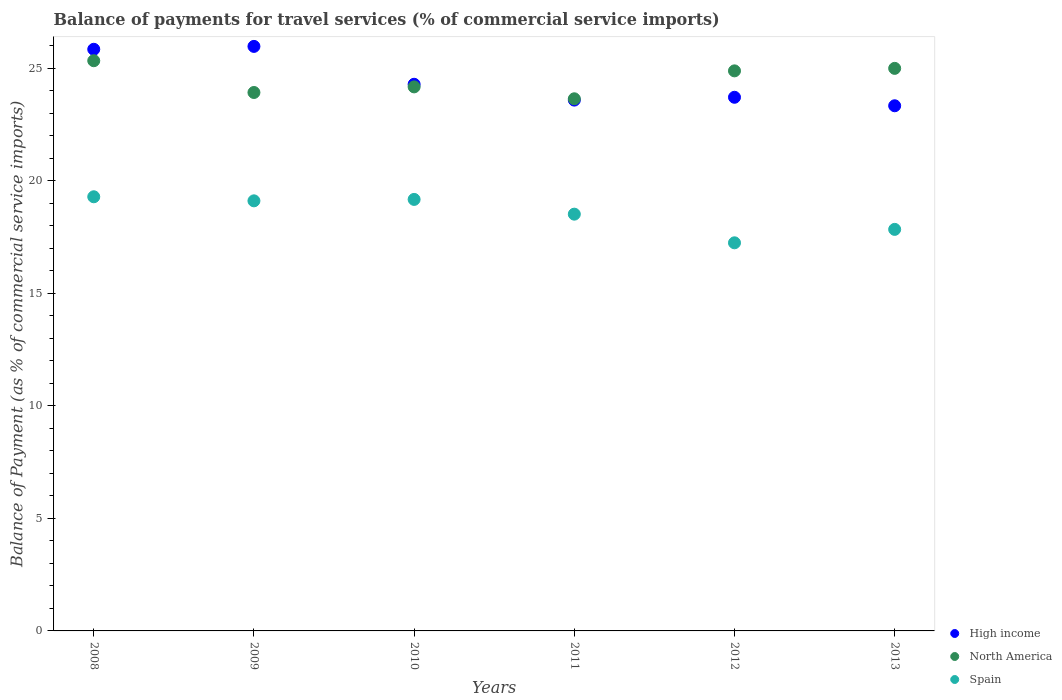How many different coloured dotlines are there?
Your answer should be very brief. 3. What is the balance of payments for travel services in Spain in 2013?
Your answer should be very brief. 17.84. Across all years, what is the maximum balance of payments for travel services in North America?
Keep it short and to the point. 25.33. Across all years, what is the minimum balance of payments for travel services in Spain?
Give a very brief answer. 17.24. In which year was the balance of payments for travel services in North America minimum?
Keep it short and to the point. 2011. What is the total balance of payments for travel services in North America in the graph?
Ensure brevity in your answer.  146.91. What is the difference between the balance of payments for travel services in North America in 2009 and that in 2013?
Provide a succinct answer. -1.07. What is the difference between the balance of payments for travel services in Spain in 2011 and the balance of payments for travel services in North America in 2012?
Your answer should be compact. -6.36. What is the average balance of payments for travel services in High income per year?
Offer a terse response. 24.45. In the year 2008, what is the difference between the balance of payments for travel services in High income and balance of payments for travel services in North America?
Give a very brief answer. 0.51. What is the ratio of the balance of payments for travel services in Spain in 2009 to that in 2011?
Give a very brief answer. 1.03. Is the balance of payments for travel services in High income in 2012 less than that in 2013?
Offer a very short reply. No. Is the difference between the balance of payments for travel services in High income in 2010 and 2011 greater than the difference between the balance of payments for travel services in North America in 2010 and 2011?
Provide a succinct answer. Yes. What is the difference between the highest and the second highest balance of payments for travel services in High income?
Make the answer very short. 0.13. What is the difference between the highest and the lowest balance of payments for travel services in North America?
Provide a succinct answer. 1.69. In how many years, is the balance of payments for travel services in North America greater than the average balance of payments for travel services in North America taken over all years?
Provide a short and direct response. 3. Is the sum of the balance of payments for travel services in High income in 2008 and 2009 greater than the maximum balance of payments for travel services in Spain across all years?
Your answer should be very brief. Yes. Is it the case that in every year, the sum of the balance of payments for travel services in North America and balance of payments for travel services in Spain  is greater than the balance of payments for travel services in High income?
Give a very brief answer. Yes. Does the balance of payments for travel services in High income monotonically increase over the years?
Offer a terse response. No. Is the balance of payments for travel services in North America strictly greater than the balance of payments for travel services in Spain over the years?
Provide a short and direct response. Yes. What is the difference between two consecutive major ticks on the Y-axis?
Your answer should be compact. 5. Are the values on the major ticks of Y-axis written in scientific E-notation?
Ensure brevity in your answer.  No. Does the graph contain any zero values?
Provide a short and direct response. No. What is the title of the graph?
Provide a succinct answer. Balance of payments for travel services (% of commercial service imports). What is the label or title of the Y-axis?
Your answer should be compact. Balance of Payment (as % of commercial service imports). What is the Balance of Payment (as % of commercial service imports) of High income in 2008?
Your response must be concise. 25.84. What is the Balance of Payment (as % of commercial service imports) of North America in 2008?
Your answer should be compact. 25.33. What is the Balance of Payment (as % of commercial service imports) in Spain in 2008?
Offer a terse response. 19.28. What is the Balance of Payment (as % of commercial service imports) of High income in 2009?
Give a very brief answer. 25.96. What is the Balance of Payment (as % of commercial service imports) of North America in 2009?
Your response must be concise. 23.92. What is the Balance of Payment (as % of commercial service imports) of Spain in 2009?
Provide a short and direct response. 19.1. What is the Balance of Payment (as % of commercial service imports) in High income in 2010?
Your response must be concise. 24.28. What is the Balance of Payment (as % of commercial service imports) of North America in 2010?
Offer a terse response. 24.17. What is the Balance of Payment (as % of commercial service imports) of Spain in 2010?
Provide a succinct answer. 19.17. What is the Balance of Payment (as % of commercial service imports) in High income in 2011?
Ensure brevity in your answer.  23.58. What is the Balance of Payment (as % of commercial service imports) of North America in 2011?
Provide a short and direct response. 23.64. What is the Balance of Payment (as % of commercial service imports) in Spain in 2011?
Make the answer very short. 18.51. What is the Balance of Payment (as % of commercial service imports) of High income in 2012?
Offer a very short reply. 23.7. What is the Balance of Payment (as % of commercial service imports) of North America in 2012?
Provide a short and direct response. 24.88. What is the Balance of Payment (as % of commercial service imports) in Spain in 2012?
Your answer should be compact. 17.24. What is the Balance of Payment (as % of commercial service imports) of High income in 2013?
Your answer should be compact. 23.33. What is the Balance of Payment (as % of commercial service imports) of North America in 2013?
Keep it short and to the point. 24.99. What is the Balance of Payment (as % of commercial service imports) of Spain in 2013?
Give a very brief answer. 17.84. Across all years, what is the maximum Balance of Payment (as % of commercial service imports) of High income?
Keep it short and to the point. 25.96. Across all years, what is the maximum Balance of Payment (as % of commercial service imports) in North America?
Your answer should be very brief. 25.33. Across all years, what is the maximum Balance of Payment (as % of commercial service imports) of Spain?
Offer a terse response. 19.28. Across all years, what is the minimum Balance of Payment (as % of commercial service imports) in High income?
Your answer should be very brief. 23.33. Across all years, what is the minimum Balance of Payment (as % of commercial service imports) in North America?
Your response must be concise. 23.64. Across all years, what is the minimum Balance of Payment (as % of commercial service imports) of Spain?
Your answer should be very brief. 17.24. What is the total Balance of Payment (as % of commercial service imports) in High income in the graph?
Offer a terse response. 146.69. What is the total Balance of Payment (as % of commercial service imports) of North America in the graph?
Provide a succinct answer. 146.91. What is the total Balance of Payment (as % of commercial service imports) in Spain in the graph?
Ensure brevity in your answer.  111.14. What is the difference between the Balance of Payment (as % of commercial service imports) of High income in 2008 and that in 2009?
Offer a terse response. -0.13. What is the difference between the Balance of Payment (as % of commercial service imports) in North America in 2008 and that in 2009?
Ensure brevity in your answer.  1.41. What is the difference between the Balance of Payment (as % of commercial service imports) of Spain in 2008 and that in 2009?
Offer a very short reply. 0.18. What is the difference between the Balance of Payment (as % of commercial service imports) in High income in 2008 and that in 2010?
Make the answer very short. 1.55. What is the difference between the Balance of Payment (as % of commercial service imports) of North America in 2008 and that in 2010?
Keep it short and to the point. 1.16. What is the difference between the Balance of Payment (as % of commercial service imports) of Spain in 2008 and that in 2010?
Your response must be concise. 0.12. What is the difference between the Balance of Payment (as % of commercial service imports) of High income in 2008 and that in 2011?
Make the answer very short. 2.26. What is the difference between the Balance of Payment (as % of commercial service imports) of North America in 2008 and that in 2011?
Offer a very short reply. 1.69. What is the difference between the Balance of Payment (as % of commercial service imports) in Spain in 2008 and that in 2011?
Provide a succinct answer. 0.77. What is the difference between the Balance of Payment (as % of commercial service imports) in High income in 2008 and that in 2012?
Offer a terse response. 2.13. What is the difference between the Balance of Payment (as % of commercial service imports) of North America in 2008 and that in 2012?
Provide a succinct answer. 0.45. What is the difference between the Balance of Payment (as % of commercial service imports) in Spain in 2008 and that in 2012?
Offer a terse response. 2.05. What is the difference between the Balance of Payment (as % of commercial service imports) of High income in 2008 and that in 2013?
Offer a terse response. 2.51. What is the difference between the Balance of Payment (as % of commercial service imports) in North America in 2008 and that in 2013?
Your answer should be very brief. 0.34. What is the difference between the Balance of Payment (as % of commercial service imports) in Spain in 2008 and that in 2013?
Make the answer very short. 1.45. What is the difference between the Balance of Payment (as % of commercial service imports) in High income in 2009 and that in 2010?
Give a very brief answer. 1.68. What is the difference between the Balance of Payment (as % of commercial service imports) in North America in 2009 and that in 2010?
Offer a terse response. -0.25. What is the difference between the Balance of Payment (as % of commercial service imports) in Spain in 2009 and that in 2010?
Ensure brevity in your answer.  -0.06. What is the difference between the Balance of Payment (as % of commercial service imports) in High income in 2009 and that in 2011?
Provide a succinct answer. 2.39. What is the difference between the Balance of Payment (as % of commercial service imports) of North America in 2009 and that in 2011?
Your answer should be compact. 0.28. What is the difference between the Balance of Payment (as % of commercial service imports) in Spain in 2009 and that in 2011?
Keep it short and to the point. 0.59. What is the difference between the Balance of Payment (as % of commercial service imports) of High income in 2009 and that in 2012?
Your response must be concise. 2.26. What is the difference between the Balance of Payment (as % of commercial service imports) in North America in 2009 and that in 2012?
Your response must be concise. -0.96. What is the difference between the Balance of Payment (as % of commercial service imports) in Spain in 2009 and that in 2012?
Make the answer very short. 1.86. What is the difference between the Balance of Payment (as % of commercial service imports) of High income in 2009 and that in 2013?
Your answer should be compact. 2.64. What is the difference between the Balance of Payment (as % of commercial service imports) in North America in 2009 and that in 2013?
Keep it short and to the point. -1.07. What is the difference between the Balance of Payment (as % of commercial service imports) in Spain in 2009 and that in 2013?
Make the answer very short. 1.27. What is the difference between the Balance of Payment (as % of commercial service imports) in High income in 2010 and that in 2011?
Offer a terse response. 0.7. What is the difference between the Balance of Payment (as % of commercial service imports) of North America in 2010 and that in 2011?
Offer a terse response. 0.53. What is the difference between the Balance of Payment (as % of commercial service imports) of Spain in 2010 and that in 2011?
Offer a terse response. 0.65. What is the difference between the Balance of Payment (as % of commercial service imports) of High income in 2010 and that in 2012?
Offer a terse response. 0.58. What is the difference between the Balance of Payment (as % of commercial service imports) in North America in 2010 and that in 2012?
Provide a succinct answer. -0.71. What is the difference between the Balance of Payment (as % of commercial service imports) in Spain in 2010 and that in 2012?
Your answer should be compact. 1.93. What is the difference between the Balance of Payment (as % of commercial service imports) in High income in 2010 and that in 2013?
Ensure brevity in your answer.  0.95. What is the difference between the Balance of Payment (as % of commercial service imports) of North America in 2010 and that in 2013?
Give a very brief answer. -0.82. What is the difference between the Balance of Payment (as % of commercial service imports) of Spain in 2010 and that in 2013?
Offer a very short reply. 1.33. What is the difference between the Balance of Payment (as % of commercial service imports) in High income in 2011 and that in 2012?
Your answer should be compact. -0.13. What is the difference between the Balance of Payment (as % of commercial service imports) in North America in 2011 and that in 2012?
Ensure brevity in your answer.  -1.24. What is the difference between the Balance of Payment (as % of commercial service imports) of Spain in 2011 and that in 2012?
Ensure brevity in your answer.  1.27. What is the difference between the Balance of Payment (as % of commercial service imports) of High income in 2011 and that in 2013?
Provide a short and direct response. 0.25. What is the difference between the Balance of Payment (as % of commercial service imports) in North America in 2011 and that in 2013?
Your answer should be compact. -1.35. What is the difference between the Balance of Payment (as % of commercial service imports) of Spain in 2011 and that in 2013?
Provide a succinct answer. 0.68. What is the difference between the Balance of Payment (as % of commercial service imports) in High income in 2012 and that in 2013?
Give a very brief answer. 0.38. What is the difference between the Balance of Payment (as % of commercial service imports) in North America in 2012 and that in 2013?
Provide a succinct answer. -0.11. What is the difference between the Balance of Payment (as % of commercial service imports) in Spain in 2012 and that in 2013?
Offer a very short reply. -0.6. What is the difference between the Balance of Payment (as % of commercial service imports) in High income in 2008 and the Balance of Payment (as % of commercial service imports) in North America in 2009?
Make the answer very short. 1.92. What is the difference between the Balance of Payment (as % of commercial service imports) of High income in 2008 and the Balance of Payment (as % of commercial service imports) of Spain in 2009?
Ensure brevity in your answer.  6.73. What is the difference between the Balance of Payment (as % of commercial service imports) of North America in 2008 and the Balance of Payment (as % of commercial service imports) of Spain in 2009?
Provide a short and direct response. 6.22. What is the difference between the Balance of Payment (as % of commercial service imports) in High income in 2008 and the Balance of Payment (as % of commercial service imports) in North America in 2010?
Your answer should be very brief. 1.67. What is the difference between the Balance of Payment (as % of commercial service imports) of High income in 2008 and the Balance of Payment (as % of commercial service imports) of Spain in 2010?
Your answer should be compact. 6.67. What is the difference between the Balance of Payment (as % of commercial service imports) in North America in 2008 and the Balance of Payment (as % of commercial service imports) in Spain in 2010?
Ensure brevity in your answer.  6.16. What is the difference between the Balance of Payment (as % of commercial service imports) in High income in 2008 and the Balance of Payment (as % of commercial service imports) in North America in 2011?
Provide a succinct answer. 2.2. What is the difference between the Balance of Payment (as % of commercial service imports) of High income in 2008 and the Balance of Payment (as % of commercial service imports) of Spain in 2011?
Give a very brief answer. 7.32. What is the difference between the Balance of Payment (as % of commercial service imports) of North America in 2008 and the Balance of Payment (as % of commercial service imports) of Spain in 2011?
Offer a very short reply. 6.82. What is the difference between the Balance of Payment (as % of commercial service imports) of High income in 2008 and the Balance of Payment (as % of commercial service imports) of North America in 2012?
Provide a short and direct response. 0.96. What is the difference between the Balance of Payment (as % of commercial service imports) in High income in 2008 and the Balance of Payment (as % of commercial service imports) in Spain in 2012?
Make the answer very short. 8.6. What is the difference between the Balance of Payment (as % of commercial service imports) in North America in 2008 and the Balance of Payment (as % of commercial service imports) in Spain in 2012?
Provide a succinct answer. 8.09. What is the difference between the Balance of Payment (as % of commercial service imports) in High income in 2008 and the Balance of Payment (as % of commercial service imports) in North America in 2013?
Offer a terse response. 0.85. What is the difference between the Balance of Payment (as % of commercial service imports) in High income in 2008 and the Balance of Payment (as % of commercial service imports) in Spain in 2013?
Offer a very short reply. 8. What is the difference between the Balance of Payment (as % of commercial service imports) of North America in 2008 and the Balance of Payment (as % of commercial service imports) of Spain in 2013?
Provide a succinct answer. 7.49. What is the difference between the Balance of Payment (as % of commercial service imports) of High income in 2009 and the Balance of Payment (as % of commercial service imports) of North America in 2010?
Offer a terse response. 1.8. What is the difference between the Balance of Payment (as % of commercial service imports) in High income in 2009 and the Balance of Payment (as % of commercial service imports) in Spain in 2010?
Give a very brief answer. 6.8. What is the difference between the Balance of Payment (as % of commercial service imports) of North America in 2009 and the Balance of Payment (as % of commercial service imports) of Spain in 2010?
Keep it short and to the point. 4.75. What is the difference between the Balance of Payment (as % of commercial service imports) in High income in 2009 and the Balance of Payment (as % of commercial service imports) in North America in 2011?
Offer a terse response. 2.33. What is the difference between the Balance of Payment (as % of commercial service imports) in High income in 2009 and the Balance of Payment (as % of commercial service imports) in Spain in 2011?
Ensure brevity in your answer.  7.45. What is the difference between the Balance of Payment (as % of commercial service imports) of North America in 2009 and the Balance of Payment (as % of commercial service imports) of Spain in 2011?
Offer a very short reply. 5.4. What is the difference between the Balance of Payment (as % of commercial service imports) in High income in 2009 and the Balance of Payment (as % of commercial service imports) in North America in 2012?
Provide a short and direct response. 1.09. What is the difference between the Balance of Payment (as % of commercial service imports) of High income in 2009 and the Balance of Payment (as % of commercial service imports) of Spain in 2012?
Make the answer very short. 8.72. What is the difference between the Balance of Payment (as % of commercial service imports) in North America in 2009 and the Balance of Payment (as % of commercial service imports) in Spain in 2012?
Make the answer very short. 6.68. What is the difference between the Balance of Payment (as % of commercial service imports) in High income in 2009 and the Balance of Payment (as % of commercial service imports) in North America in 2013?
Your answer should be very brief. 0.98. What is the difference between the Balance of Payment (as % of commercial service imports) in High income in 2009 and the Balance of Payment (as % of commercial service imports) in Spain in 2013?
Provide a succinct answer. 8.13. What is the difference between the Balance of Payment (as % of commercial service imports) of North America in 2009 and the Balance of Payment (as % of commercial service imports) of Spain in 2013?
Offer a very short reply. 6.08. What is the difference between the Balance of Payment (as % of commercial service imports) in High income in 2010 and the Balance of Payment (as % of commercial service imports) in North America in 2011?
Offer a terse response. 0.65. What is the difference between the Balance of Payment (as % of commercial service imports) in High income in 2010 and the Balance of Payment (as % of commercial service imports) in Spain in 2011?
Provide a succinct answer. 5.77. What is the difference between the Balance of Payment (as % of commercial service imports) of North America in 2010 and the Balance of Payment (as % of commercial service imports) of Spain in 2011?
Offer a very short reply. 5.65. What is the difference between the Balance of Payment (as % of commercial service imports) of High income in 2010 and the Balance of Payment (as % of commercial service imports) of North America in 2012?
Make the answer very short. -0.6. What is the difference between the Balance of Payment (as % of commercial service imports) of High income in 2010 and the Balance of Payment (as % of commercial service imports) of Spain in 2012?
Offer a terse response. 7.04. What is the difference between the Balance of Payment (as % of commercial service imports) in North America in 2010 and the Balance of Payment (as % of commercial service imports) in Spain in 2012?
Make the answer very short. 6.93. What is the difference between the Balance of Payment (as % of commercial service imports) in High income in 2010 and the Balance of Payment (as % of commercial service imports) in North America in 2013?
Provide a short and direct response. -0.71. What is the difference between the Balance of Payment (as % of commercial service imports) in High income in 2010 and the Balance of Payment (as % of commercial service imports) in Spain in 2013?
Your response must be concise. 6.45. What is the difference between the Balance of Payment (as % of commercial service imports) of North America in 2010 and the Balance of Payment (as % of commercial service imports) of Spain in 2013?
Keep it short and to the point. 6.33. What is the difference between the Balance of Payment (as % of commercial service imports) of High income in 2011 and the Balance of Payment (as % of commercial service imports) of North America in 2012?
Your answer should be compact. -1.3. What is the difference between the Balance of Payment (as % of commercial service imports) of High income in 2011 and the Balance of Payment (as % of commercial service imports) of Spain in 2012?
Provide a short and direct response. 6.34. What is the difference between the Balance of Payment (as % of commercial service imports) in North America in 2011 and the Balance of Payment (as % of commercial service imports) in Spain in 2012?
Offer a very short reply. 6.4. What is the difference between the Balance of Payment (as % of commercial service imports) in High income in 2011 and the Balance of Payment (as % of commercial service imports) in North America in 2013?
Your answer should be very brief. -1.41. What is the difference between the Balance of Payment (as % of commercial service imports) of High income in 2011 and the Balance of Payment (as % of commercial service imports) of Spain in 2013?
Make the answer very short. 5.74. What is the difference between the Balance of Payment (as % of commercial service imports) in North America in 2011 and the Balance of Payment (as % of commercial service imports) in Spain in 2013?
Make the answer very short. 5.8. What is the difference between the Balance of Payment (as % of commercial service imports) in High income in 2012 and the Balance of Payment (as % of commercial service imports) in North America in 2013?
Your response must be concise. -1.28. What is the difference between the Balance of Payment (as % of commercial service imports) of High income in 2012 and the Balance of Payment (as % of commercial service imports) of Spain in 2013?
Your answer should be compact. 5.87. What is the difference between the Balance of Payment (as % of commercial service imports) of North America in 2012 and the Balance of Payment (as % of commercial service imports) of Spain in 2013?
Your answer should be compact. 7.04. What is the average Balance of Payment (as % of commercial service imports) of High income per year?
Your answer should be very brief. 24.45. What is the average Balance of Payment (as % of commercial service imports) of North America per year?
Provide a succinct answer. 24.49. What is the average Balance of Payment (as % of commercial service imports) in Spain per year?
Provide a succinct answer. 18.52. In the year 2008, what is the difference between the Balance of Payment (as % of commercial service imports) of High income and Balance of Payment (as % of commercial service imports) of North America?
Your response must be concise. 0.51. In the year 2008, what is the difference between the Balance of Payment (as % of commercial service imports) in High income and Balance of Payment (as % of commercial service imports) in Spain?
Give a very brief answer. 6.55. In the year 2008, what is the difference between the Balance of Payment (as % of commercial service imports) of North America and Balance of Payment (as % of commercial service imports) of Spain?
Your answer should be very brief. 6.04. In the year 2009, what is the difference between the Balance of Payment (as % of commercial service imports) in High income and Balance of Payment (as % of commercial service imports) in North America?
Give a very brief answer. 2.05. In the year 2009, what is the difference between the Balance of Payment (as % of commercial service imports) in High income and Balance of Payment (as % of commercial service imports) in Spain?
Make the answer very short. 6.86. In the year 2009, what is the difference between the Balance of Payment (as % of commercial service imports) in North America and Balance of Payment (as % of commercial service imports) in Spain?
Provide a succinct answer. 4.81. In the year 2010, what is the difference between the Balance of Payment (as % of commercial service imports) of High income and Balance of Payment (as % of commercial service imports) of North America?
Your answer should be compact. 0.12. In the year 2010, what is the difference between the Balance of Payment (as % of commercial service imports) of High income and Balance of Payment (as % of commercial service imports) of Spain?
Your answer should be compact. 5.11. In the year 2010, what is the difference between the Balance of Payment (as % of commercial service imports) in North America and Balance of Payment (as % of commercial service imports) in Spain?
Your response must be concise. 5. In the year 2011, what is the difference between the Balance of Payment (as % of commercial service imports) in High income and Balance of Payment (as % of commercial service imports) in North America?
Give a very brief answer. -0.06. In the year 2011, what is the difference between the Balance of Payment (as % of commercial service imports) of High income and Balance of Payment (as % of commercial service imports) of Spain?
Provide a short and direct response. 5.07. In the year 2011, what is the difference between the Balance of Payment (as % of commercial service imports) of North America and Balance of Payment (as % of commercial service imports) of Spain?
Provide a short and direct response. 5.12. In the year 2012, what is the difference between the Balance of Payment (as % of commercial service imports) in High income and Balance of Payment (as % of commercial service imports) in North America?
Offer a terse response. -1.17. In the year 2012, what is the difference between the Balance of Payment (as % of commercial service imports) of High income and Balance of Payment (as % of commercial service imports) of Spain?
Ensure brevity in your answer.  6.46. In the year 2012, what is the difference between the Balance of Payment (as % of commercial service imports) in North America and Balance of Payment (as % of commercial service imports) in Spain?
Offer a very short reply. 7.64. In the year 2013, what is the difference between the Balance of Payment (as % of commercial service imports) of High income and Balance of Payment (as % of commercial service imports) of North America?
Your response must be concise. -1.66. In the year 2013, what is the difference between the Balance of Payment (as % of commercial service imports) in High income and Balance of Payment (as % of commercial service imports) in Spain?
Ensure brevity in your answer.  5.49. In the year 2013, what is the difference between the Balance of Payment (as % of commercial service imports) of North America and Balance of Payment (as % of commercial service imports) of Spain?
Your response must be concise. 7.15. What is the ratio of the Balance of Payment (as % of commercial service imports) in North America in 2008 to that in 2009?
Ensure brevity in your answer.  1.06. What is the ratio of the Balance of Payment (as % of commercial service imports) of Spain in 2008 to that in 2009?
Keep it short and to the point. 1.01. What is the ratio of the Balance of Payment (as % of commercial service imports) in High income in 2008 to that in 2010?
Ensure brevity in your answer.  1.06. What is the ratio of the Balance of Payment (as % of commercial service imports) in North America in 2008 to that in 2010?
Your answer should be compact. 1.05. What is the ratio of the Balance of Payment (as % of commercial service imports) of Spain in 2008 to that in 2010?
Your answer should be very brief. 1.01. What is the ratio of the Balance of Payment (as % of commercial service imports) of High income in 2008 to that in 2011?
Your answer should be very brief. 1.1. What is the ratio of the Balance of Payment (as % of commercial service imports) of North America in 2008 to that in 2011?
Provide a short and direct response. 1.07. What is the ratio of the Balance of Payment (as % of commercial service imports) of Spain in 2008 to that in 2011?
Ensure brevity in your answer.  1.04. What is the ratio of the Balance of Payment (as % of commercial service imports) in High income in 2008 to that in 2012?
Your answer should be compact. 1.09. What is the ratio of the Balance of Payment (as % of commercial service imports) in North America in 2008 to that in 2012?
Keep it short and to the point. 1.02. What is the ratio of the Balance of Payment (as % of commercial service imports) of Spain in 2008 to that in 2012?
Keep it short and to the point. 1.12. What is the ratio of the Balance of Payment (as % of commercial service imports) in High income in 2008 to that in 2013?
Your response must be concise. 1.11. What is the ratio of the Balance of Payment (as % of commercial service imports) in North America in 2008 to that in 2013?
Offer a terse response. 1.01. What is the ratio of the Balance of Payment (as % of commercial service imports) of Spain in 2008 to that in 2013?
Your answer should be very brief. 1.08. What is the ratio of the Balance of Payment (as % of commercial service imports) of High income in 2009 to that in 2010?
Make the answer very short. 1.07. What is the ratio of the Balance of Payment (as % of commercial service imports) of Spain in 2009 to that in 2010?
Make the answer very short. 1. What is the ratio of the Balance of Payment (as % of commercial service imports) of High income in 2009 to that in 2011?
Offer a terse response. 1.1. What is the ratio of the Balance of Payment (as % of commercial service imports) of North America in 2009 to that in 2011?
Your answer should be compact. 1.01. What is the ratio of the Balance of Payment (as % of commercial service imports) in Spain in 2009 to that in 2011?
Keep it short and to the point. 1.03. What is the ratio of the Balance of Payment (as % of commercial service imports) of High income in 2009 to that in 2012?
Your answer should be compact. 1.1. What is the ratio of the Balance of Payment (as % of commercial service imports) of North America in 2009 to that in 2012?
Your answer should be very brief. 0.96. What is the ratio of the Balance of Payment (as % of commercial service imports) in Spain in 2009 to that in 2012?
Provide a short and direct response. 1.11. What is the ratio of the Balance of Payment (as % of commercial service imports) in High income in 2009 to that in 2013?
Your response must be concise. 1.11. What is the ratio of the Balance of Payment (as % of commercial service imports) of North America in 2009 to that in 2013?
Ensure brevity in your answer.  0.96. What is the ratio of the Balance of Payment (as % of commercial service imports) of Spain in 2009 to that in 2013?
Provide a short and direct response. 1.07. What is the ratio of the Balance of Payment (as % of commercial service imports) in High income in 2010 to that in 2011?
Your response must be concise. 1.03. What is the ratio of the Balance of Payment (as % of commercial service imports) in North America in 2010 to that in 2011?
Offer a very short reply. 1.02. What is the ratio of the Balance of Payment (as % of commercial service imports) of Spain in 2010 to that in 2011?
Your answer should be compact. 1.04. What is the ratio of the Balance of Payment (as % of commercial service imports) in High income in 2010 to that in 2012?
Give a very brief answer. 1.02. What is the ratio of the Balance of Payment (as % of commercial service imports) in North America in 2010 to that in 2012?
Offer a very short reply. 0.97. What is the ratio of the Balance of Payment (as % of commercial service imports) in Spain in 2010 to that in 2012?
Provide a short and direct response. 1.11. What is the ratio of the Balance of Payment (as % of commercial service imports) of High income in 2010 to that in 2013?
Keep it short and to the point. 1.04. What is the ratio of the Balance of Payment (as % of commercial service imports) of North America in 2010 to that in 2013?
Keep it short and to the point. 0.97. What is the ratio of the Balance of Payment (as % of commercial service imports) of Spain in 2010 to that in 2013?
Your answer should be compact. 1.07. What is the ratio of the Balance of Payment (as % of commercial service imports) of North America in 2011 to that in 2012?
Your response must be concise. 0.95. What is the ratio of the Balance of Payment (as % of commercial service imports) in Spain in 2011 to that in 2012?
Keep it short and to the point. 1.07. What is the ratio of the Balance of Payment (as % of commercial service imports) of High income in 2011 to that in 2013?
Offer a terse response. 1.01. What is the ratio of the Balance of Payment (as % of commercial service imports) of North America in 2011 to that in 2013?
Give a very brief answer. 0.95. What is the ratio of the Balance of Payment (as % of commercial service imports) in Spain in 2011 to that in 2013?
Give a very brief answer. 1.04. What is the ratio of the Balance of Payment (as % of commercial service imports) in High income in 2012 to that in 2013?
Make the answer very short. 1.02. What is the ratio of the Balance of Payment (as % of commercial service imports) in Spain in 2012 to that in 2013?
Offer a very short reply. 0.97. What is the difference between the highest and the second highest Balance of Payment (as % of commercial service imports) in High income?
Offer a very short reply. 0.13. What is the difference between the highest and the second highest Balance of Payment (as % of commercial service imports) in North America?
Provide a short and direct response. 0.34. What is the difference between the highest and the second highest Balance of Payment (as % of commercial service imports) in Spain?
Offer a terse response. 0.12. What is the difference between the highest and the lowest Balance of Payment (as % of commercial service imports) of High income?
Your answer should be very brief. 2.64. What is the difference between the highest and the lowest Balance of Payment (as % of commercial service imports) in North America?
Offer a terse response. 1.69. What is the difference between the highest and the lowest Balance of Payment (as % of commercial service imports) of Spain?
Give a very brief answer. 2.05. 